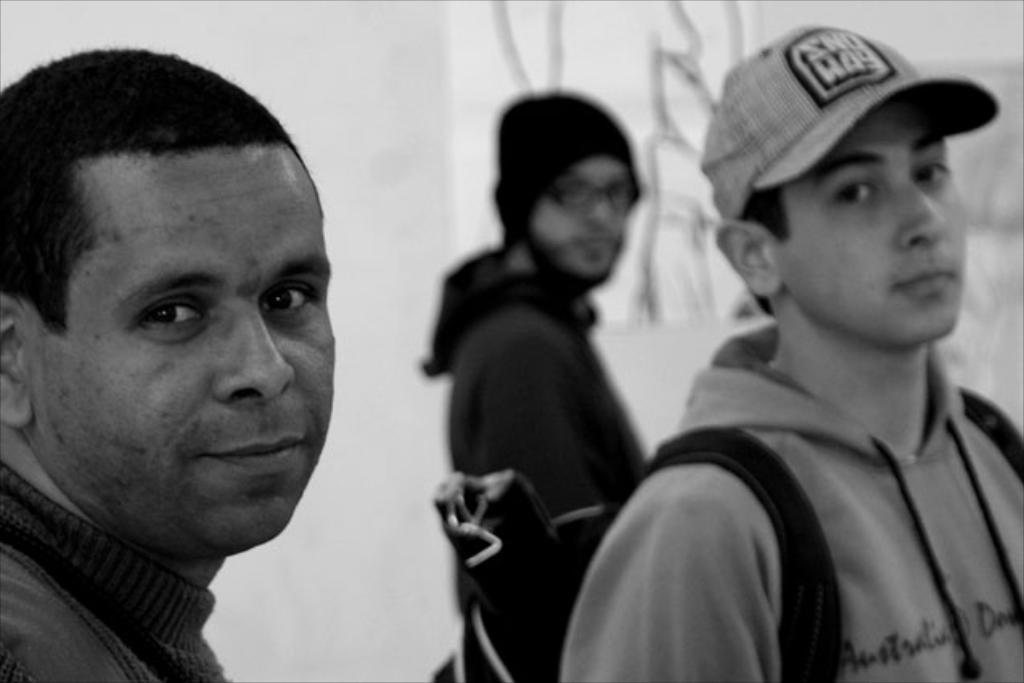What is the main subject of the image? The main subject of the image is a group of people. Can you describe the man on the right side of the image? The man on the right side of the image is wearing a cap. What is the color scheme of the image? The image is in black and white. Can you see any crayons being used by the group of people in the image? There are no crayons present in the image. Is the river visible in the background of the image? There is no river visible in the image. 